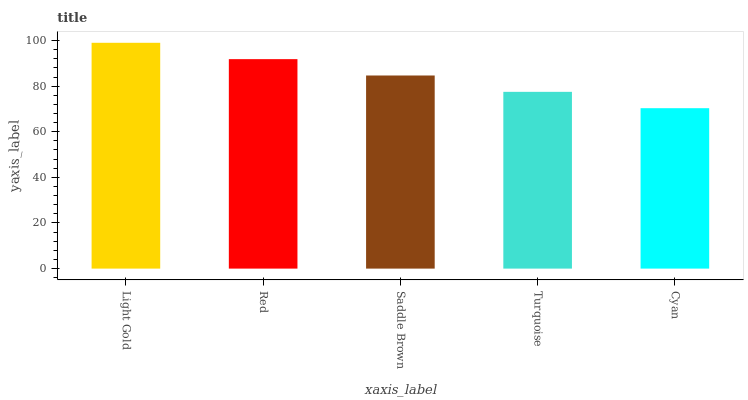Is Cyan the minimum?
Answer yes or no. Yes. Is Light Gold the maximum?
Answer yes or no. Yes. Is Red the minimum?
Answer yes or no. No. Is Red the maximum?
Answer yes or no. No. Is Light Gold greater than Red?
Answer yes or no. Yes. Is Red less than Light Gold?
Answer yes or no. Yes. Is Red greater than Light Gold?
Answer yes or no. No. Is Light Gold less than Red?
Answer yes or no. No. Is Saddle Brown the high median?
Answer yes or no. Yes. Is Saddle Brown the low median?
Answer yes or no. Yes. Is Turquoise the high median?
Answer yes or no. No. Is Light Gold the low median?
Answer yes or no. No. 